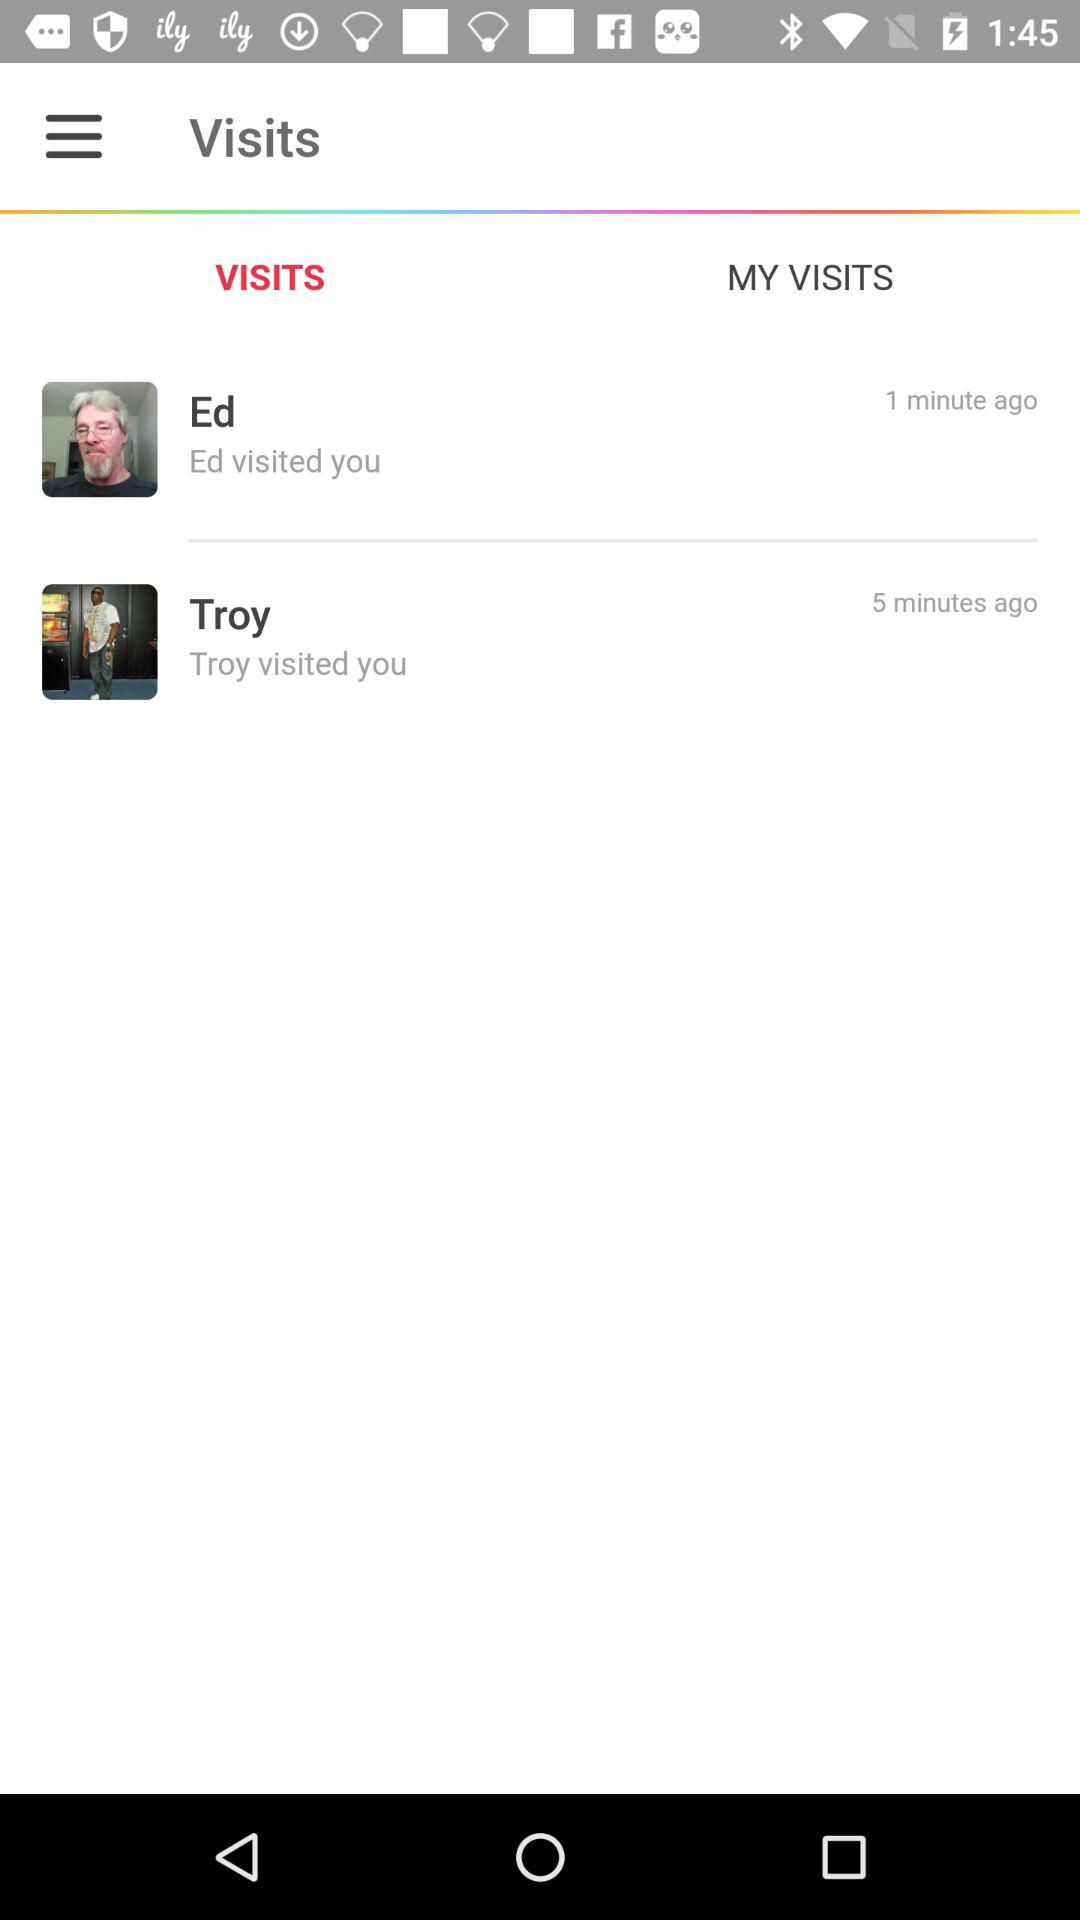How long ago did Troy visit me? Troy visited you 5 minutes ago. 